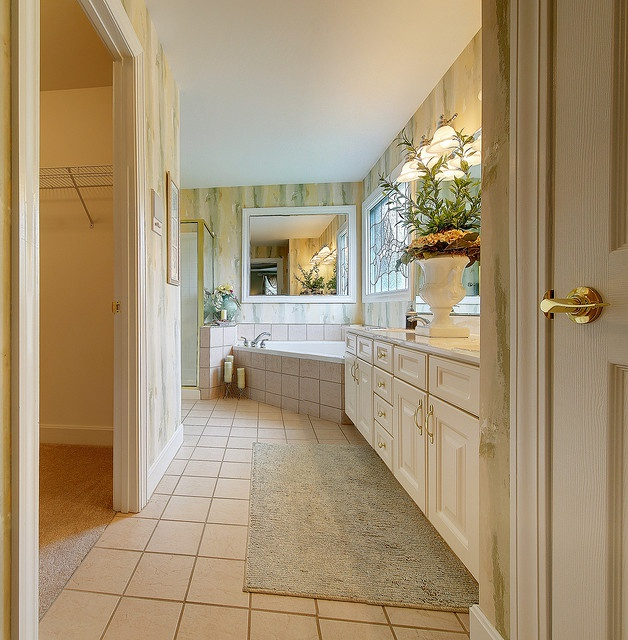Describe the objects in this image and their specific colors. I can see potted plant in tan, darkgray, ivory, and olive tones, vase in tan and darkgray tones, vase in tan, darkgray, lightblue, lightgray, and gray tones, and sink in tan, lightgray, and gray tones in this image. 